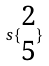Convert formula to latex. <formula><loc_0><loc_0><loc_500><loc_500>s \{ \begin{matrix} 2 \\ 5 \end{matrix} \}</formula> 